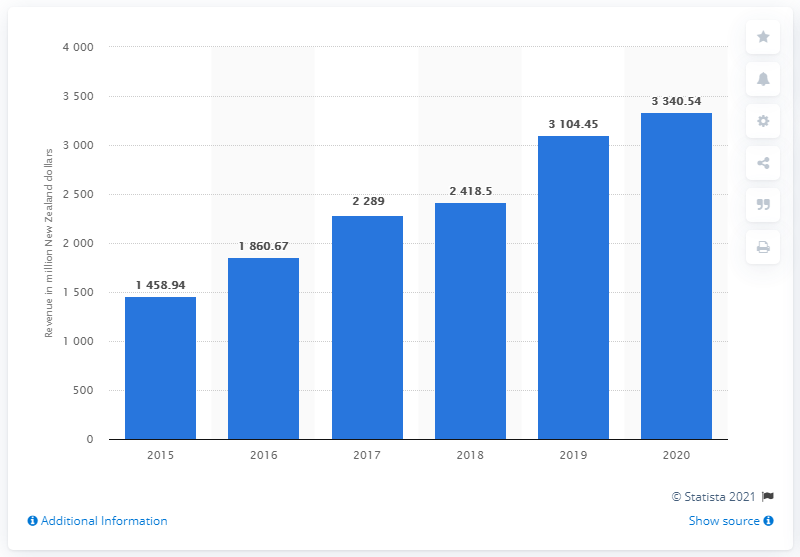Identify some key points in this picture. In the fiscal year 2020, Zespri International Limited generated a total operating revenue of 3340.54 New Zealand dollars. 